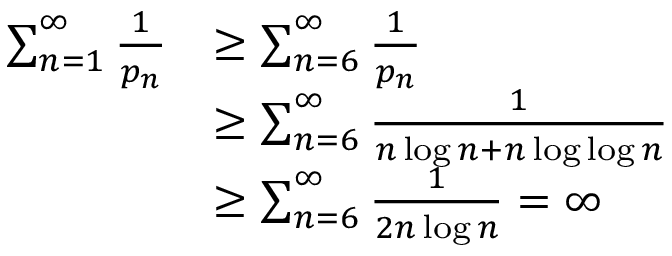<formula> <loc_0><loc_0><loc_500><loc_500>{ \begin{array} { r l } { \sum _ { n = 1 } ^ { \infty } { \frac { 1 } { p _ { n } } } } & { \geq \sum _ { n = 6 } ^ { \infty } { \frac { 1 } { p _ { n } } } } \\ & { \geq \sum _ { n = 6 } ^ { \infty } { \frac { 1 } { n \log n + n \log \log n } } } \\ & { \geq \sum _ { n = 6 } ^ { \infty } { \frac { 1 } { 2 n \log n } } = \infty } \end{array} }</formula> 